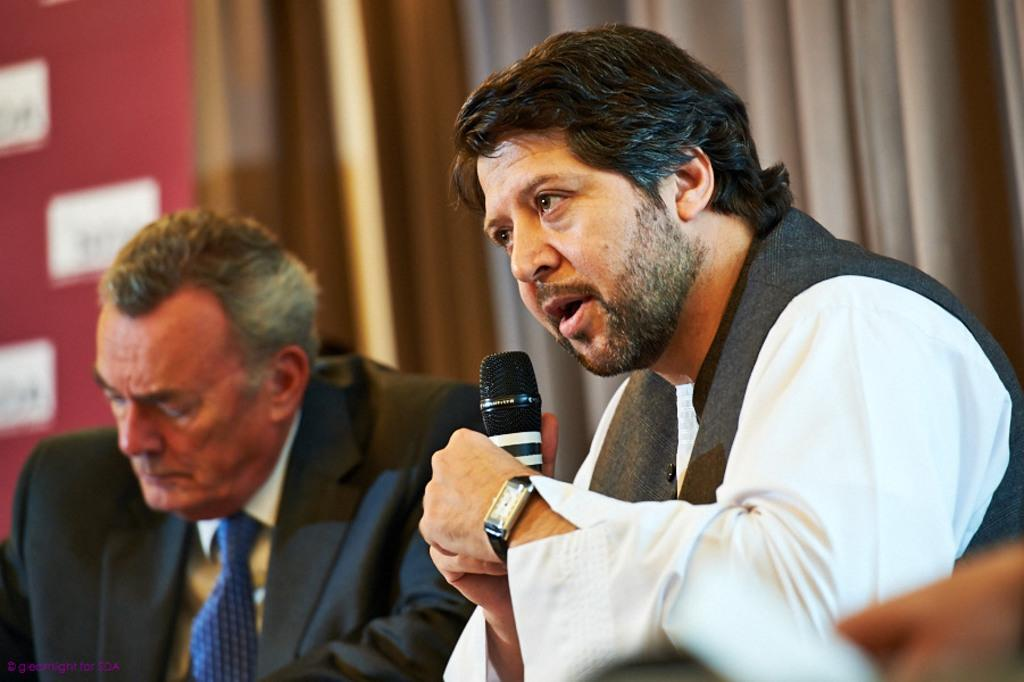What is present in the image that serves as a barrier or divider? There is a wall in the image. What is present in the image that can be used to cover or decorate the wall? There is a curtain in the image. How many people are in the image? There are two people in the image. What is the gender of one of the people in the image? One of the people is a man. What is the man in the image doing? The man is sitting. What is the man holding in the image? The man is holding a mic. What type of hose is being used to water the plants in the image? There is no hose or plants present in the image. What type of station is visible in the background of the image? There is no station visible in the image. 